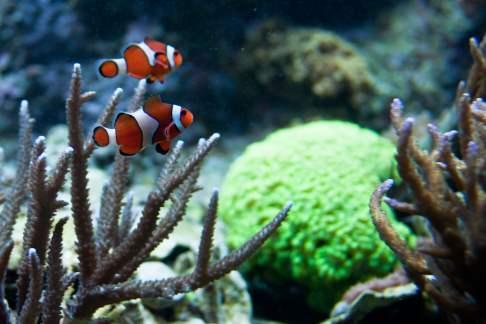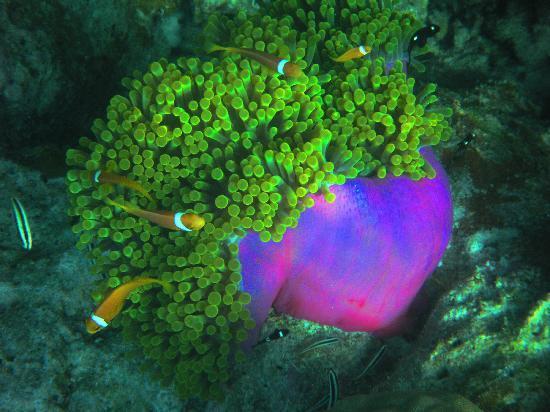The first image is the image on the left, the second image is the image on the right. Assess this claim about the two images: "There are no more than two fish in the image on the left.". Correct or not? Answer yes or no. Yes. 